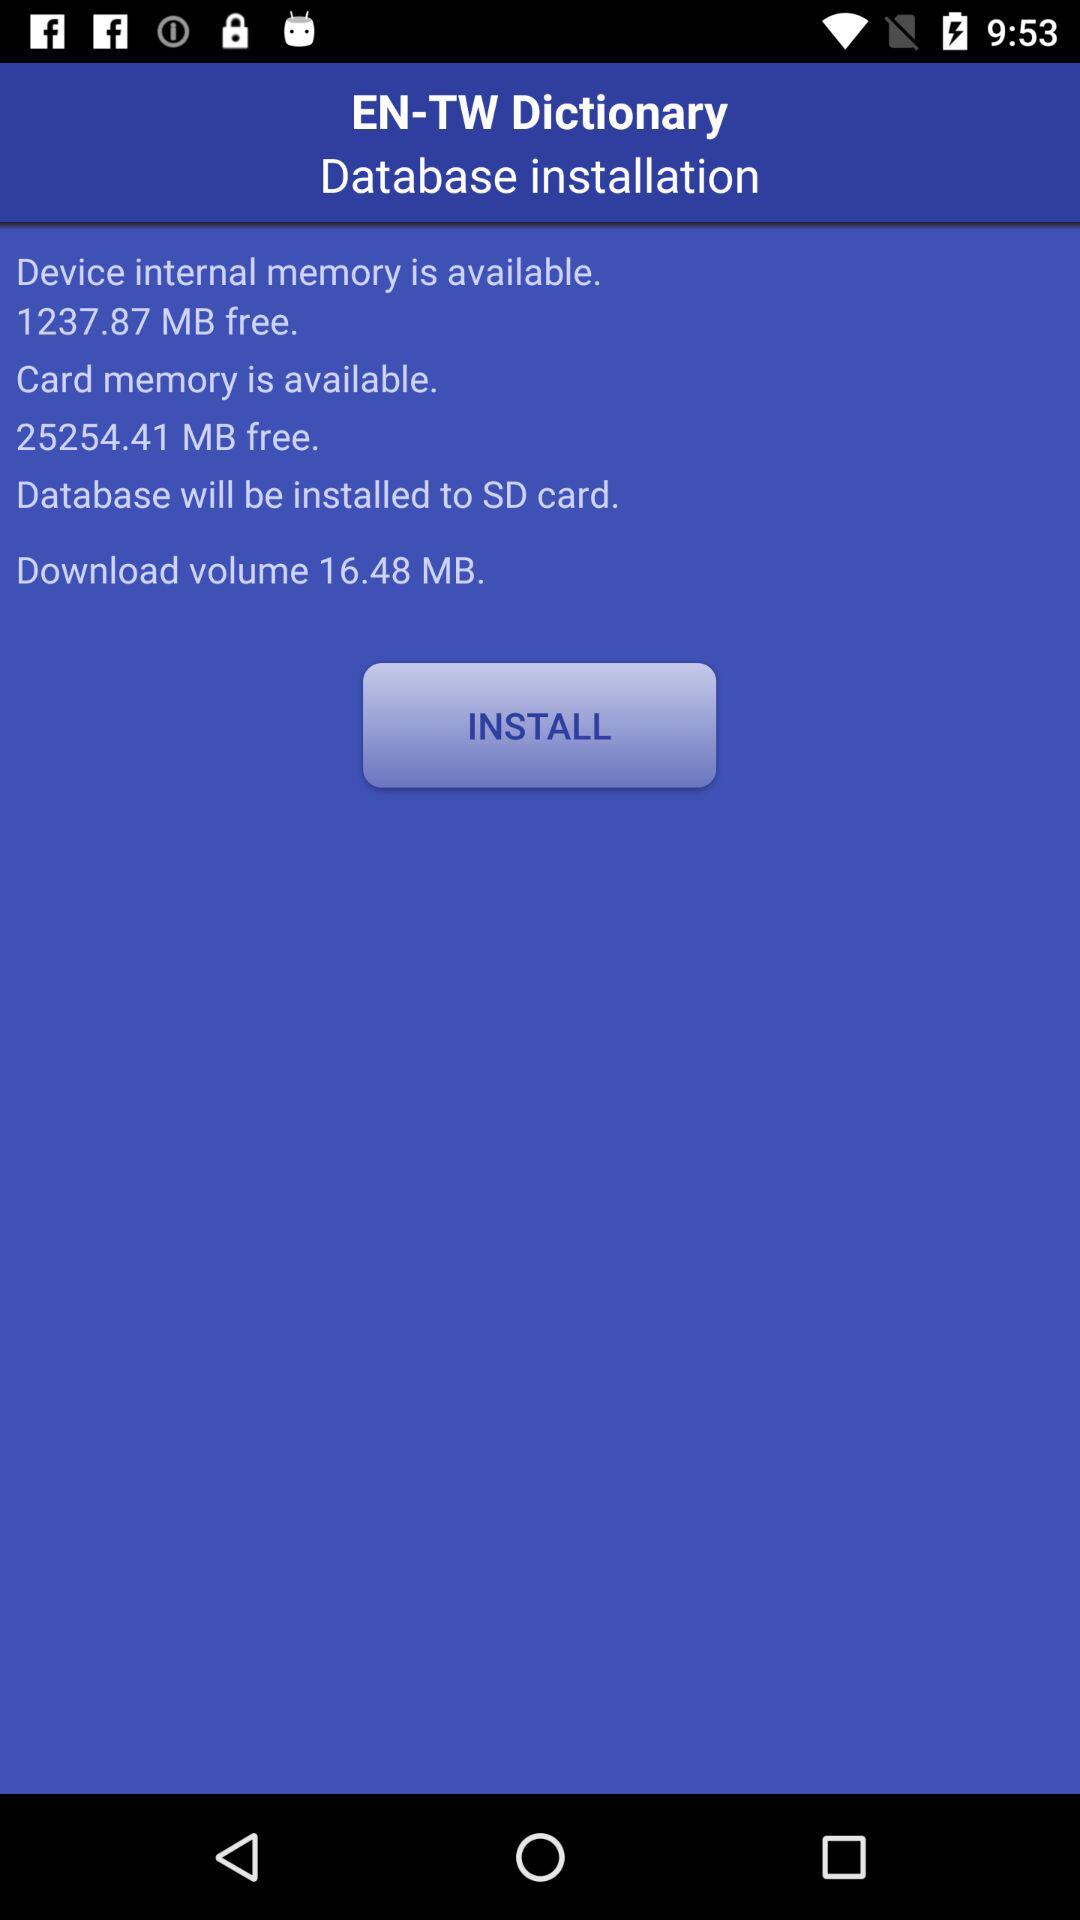How much card memory is available? The available memory on the card is 25254.41 MB. 